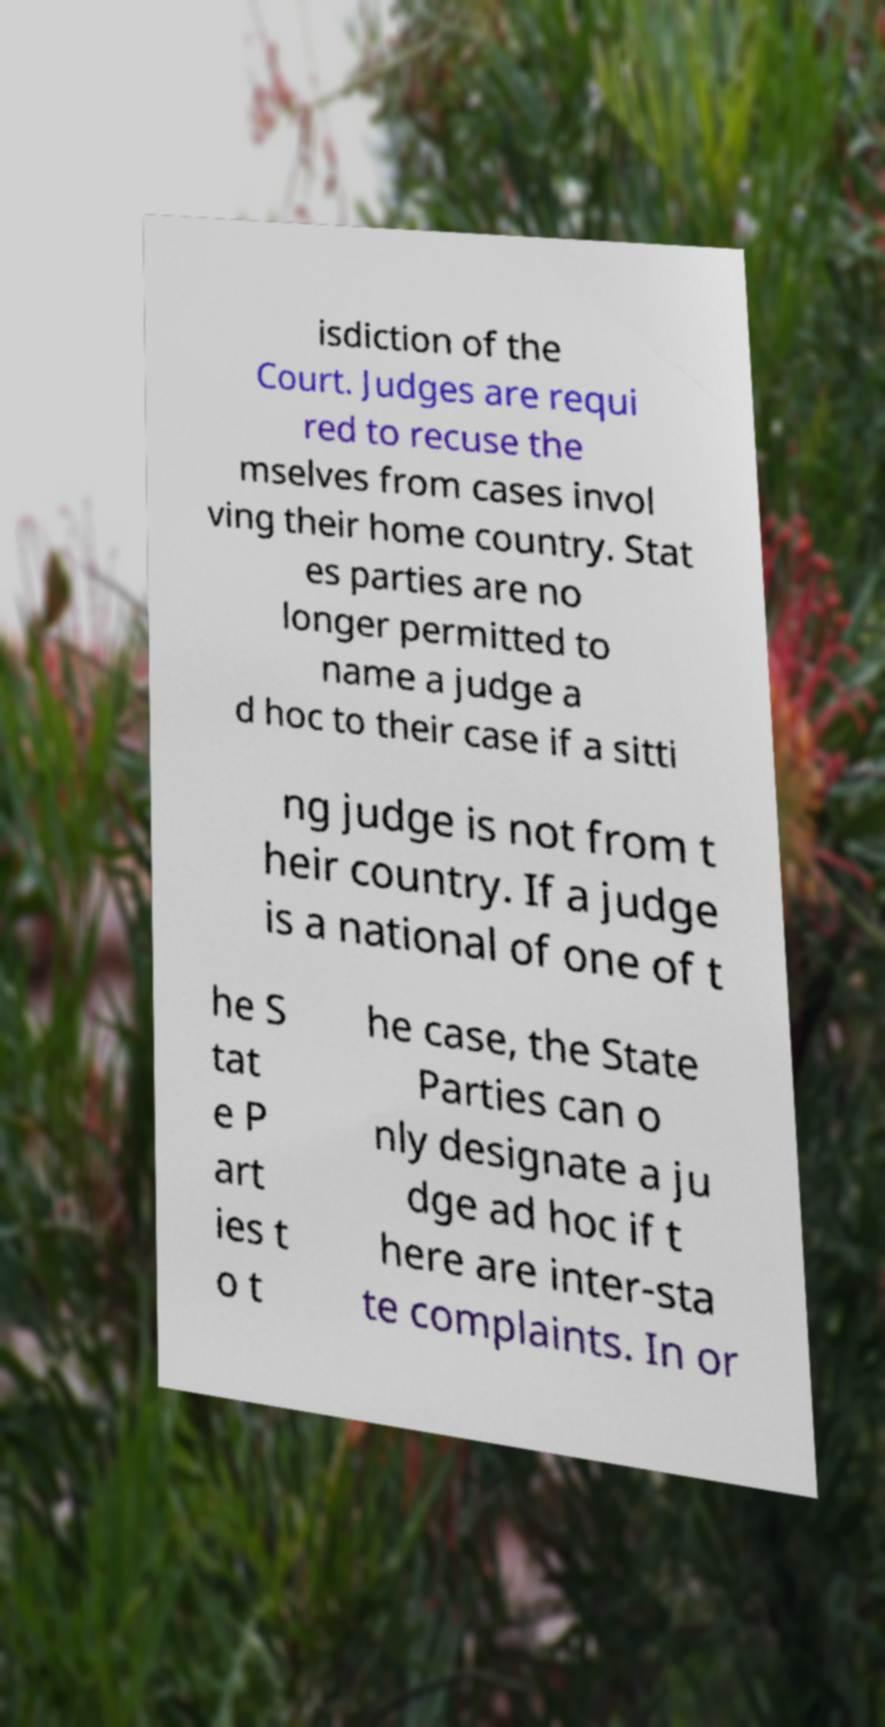Please identify and transcribe the text found in this image. isdiction of the Court. Judges are requi red to recuse the mselves from cases invol ving their home country. Stat es parties are no longer permitted to name a judge a d hoc to their case if a sitti ng judge is not from t heir country. If a judge is a national of one of t he S tat e P art ies t o t he case, the State Parties can o nly designate a ju dge ad hoc if t here are inter-sta te complaints. In or 